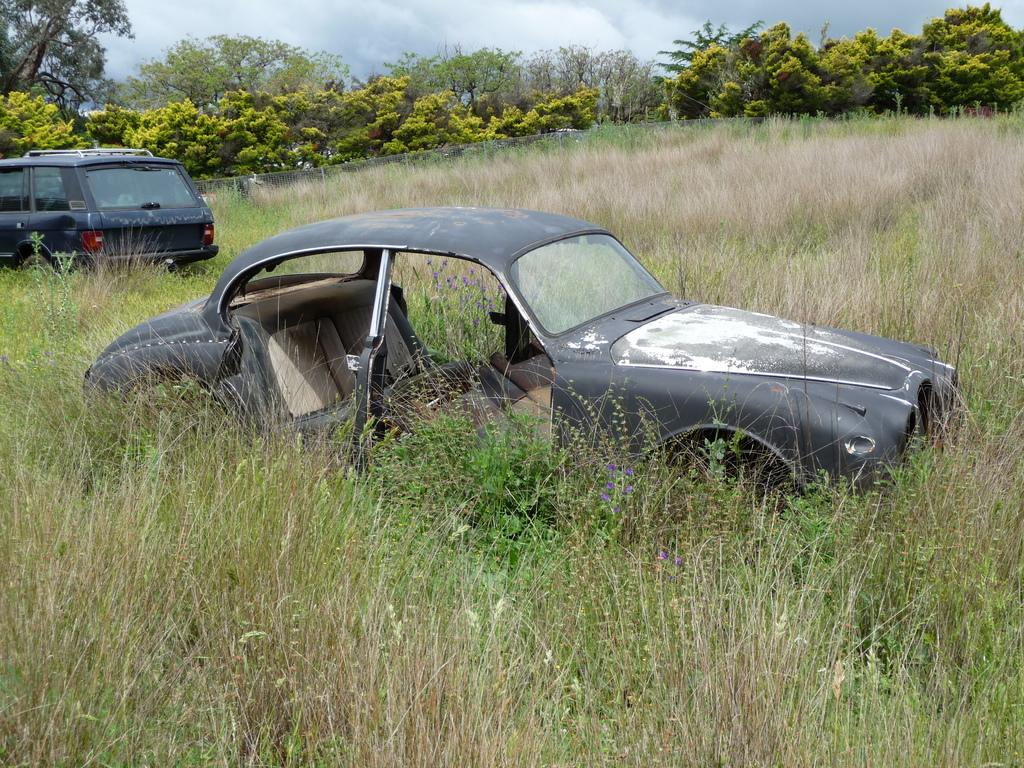How many cars are present in the image? There are two cars in the image. What other objects can be seen in the image besides the cars? There are plants visible in the image. What can be seen in the background of the image? There are trees and the sky visible in the background of the image. What type of quarter can be seen in the image? There is no quarter present in the image. How is the knife being used in the image? There is no knife present in the image. What type of lock is visible on the cars in the image? There is no lock visible on the cars in the image. 